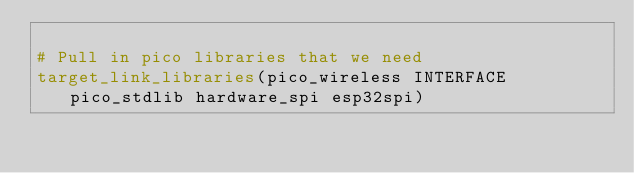<code> <loc_0><loc_0><loc_500><loc_500><_CMake_>
# Pull in pico libraries that we need
target_link_libraries(pico_wireless INTERFACE pico_stdlib hardware_spi esp32spi)
</code> 